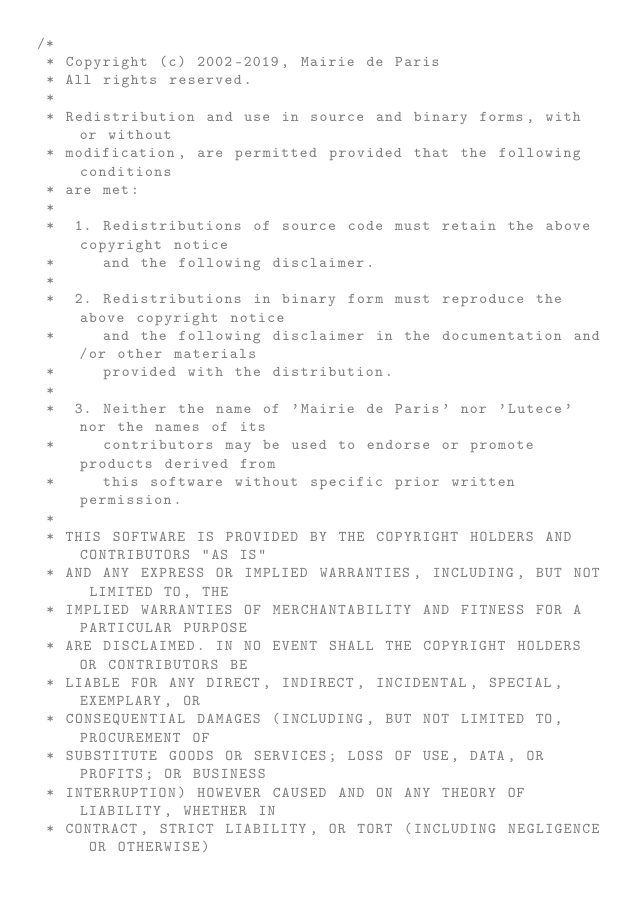Convert code to text. <code><loc_0><loc_0><loc_500><loc_500><_Java_>/*
 * Copyright (c) 2002-2019, Mairie de Paris
 * All rights reserved.
 *
 * Redistribution and use in source and binary forms, with or without
 * modification, are permitted provided that the following conditions
 * are met:
 *
 *  1. Redistributions of source code must retain the above copyright notice
 *     and the following disclaimer.
 *
 *  2. Redistributions in binary form must reproduce the above copyright notice
 *     and the following disclaimer in the documentation and/or other materials
 *     provided with the distribution.
 *
 *  3. Neither the name of 'Mairie de Paris' nor 'Lutece' nor the names of its
 *     contributors may be used to endorse or promote products derived from
 *     this software without specific prior written permission.
 *
 * THIS SOFTWARE IS PROVIDED BY THE COPYRIGHT HOLDERS AND CONTRIBUTORS "AS IS"
 * AND ANY EXPRESS OR IMPLIED WARRANTIES, INCLUDING, BUT NOT LIMITED TO, THE
 * IMPLIED WARRANTIES OF MERCHANTABILITY AND FITNESS FOR A PARTICULAR PURPOSE
 * ARE DISCLAIMED. IN NO EVENT SHALL THE COPYRIGHT HOLDERS OR CONTRIBUTORS BE
 * LIABLE FOR ANY DIRECT, INDIRECT, INCIDENTAL, SPECIAL, EXEMPLARY, OR
 * CONSEQUENTIAL DAMAGES (INCLUDING, BUT NOT LIMITED TO, PROCUREMENT OF
 * SUBSTITUTE GOODS OR SERVICES; LOSS OF USE, DATA, OR PROFITS; OR BUSINESS
 * INTERRUPTION) HOWEVER CAUSED AND ON ANY THEORY OF LIABILITY, WHETHER IN
 * CONTRACT, STRICT LIABILITY, OR TORT (INCLUDING NEGLIGENCE OR OTHERWISE)</code> 